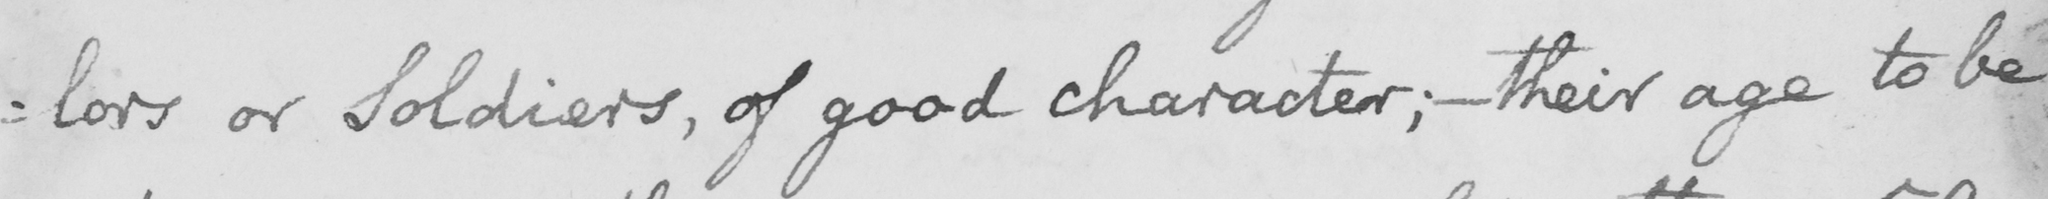Can you tell me what this handwritten text says? : lors or Soldiers , of good character ;  _  their age to be 